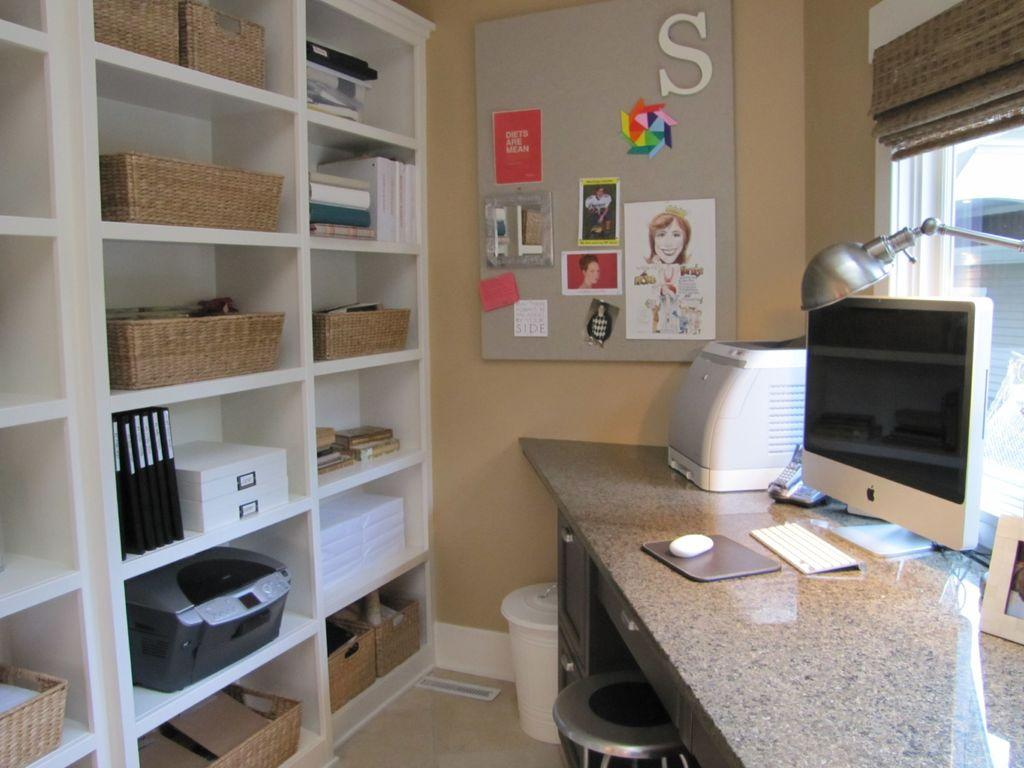<image>
Present a compact description of the photo's key features. The letter S can be seen on the bulletin board in this office space. 